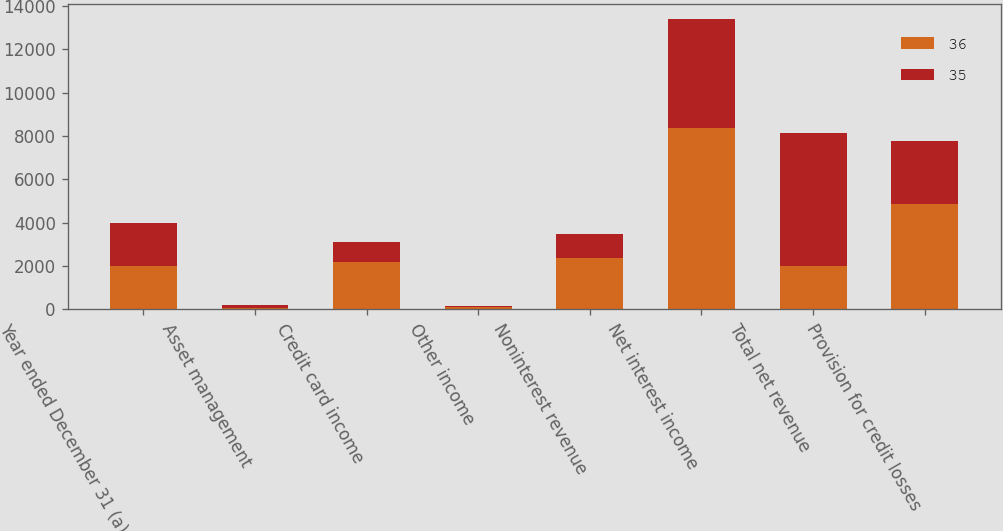<chart> <loc_0><loc_0><loc_500><loc_500><stacked_bar_chart><ecel><fcel>Year ended December 31 (a) (in<fcel>Asset management<fcel>Credit card income<fcel>Other income<fcel>Noninterest revenue<fcel>Net interest income<fcel>Total net revenue<fcel>Provision for credit losses<nl><fcel>36<fcel>2004<fcel>75<fcel>2179<fcel>117<fcel>2371<fcel>8374<fcel>2004<fcel>4851<nl><fcel>35<fcel>2003<fcel>108<fcel>930<fcel>54<fcel>1092<fcel>5052<fcel>6144<fcel>2904<nl></chart> 